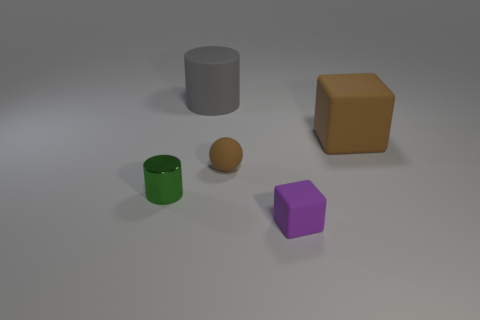Subtract all gray cylinders. How many cylinders are left? 1 Subtract all spheres. How many objects are left? 4 Add 3 large matte cylinders. How many objects exist? 8 Subtract 0 blue blocks. How many objects are left? 5 Subtract 2 cylinders. How many cylinders are left? 0 Subtract all purple cylinders. Subtract all blue spheres. How many cylinders are left? 2 Subtract all blue cylinders. How many purple cubes are left? 1 Subtract all tiny matte blocks. Subtract all large purple matte blocks. How many objects are left? 4 Add 1 small purple objects. How many small purple objects are left? 2 Add 2 large gray matte cylinders. How many large gray matte cylinders exist? 3 